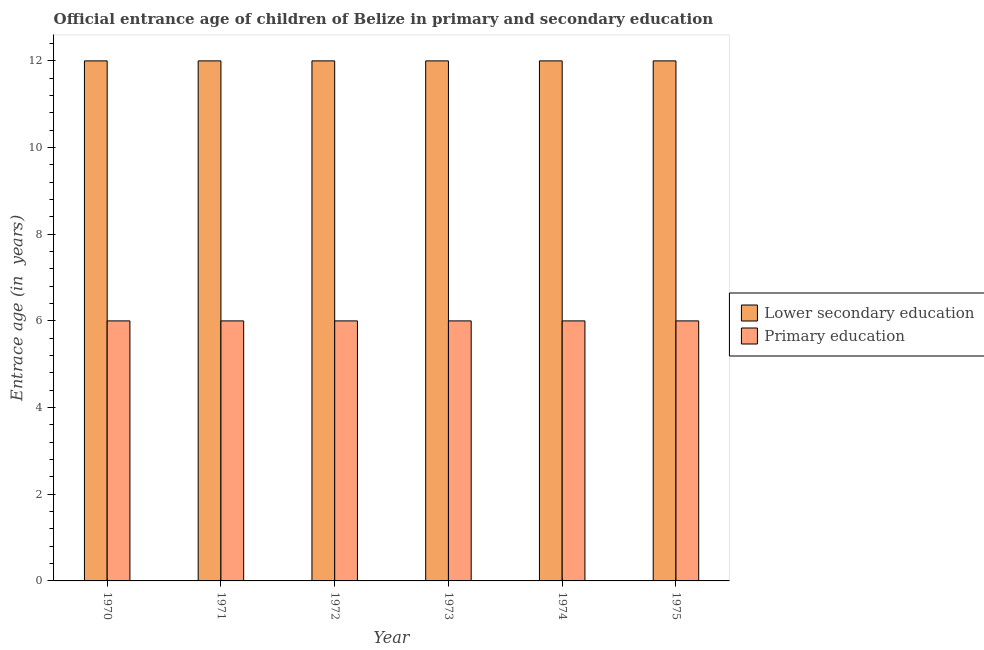How many different coloured bars are there?
Provide a short and direct response. 2. How many groups of bars are there?
Make the answer very short. 6. Are the number of bars per tick equal to the number of legend labels?
Keep it short and to the point. Yes. Are the number of bars on each tick of the X-axis equal?
Give a very brief answer. Yes. How many bars are there on the 1st tick from the left?
Keep it short and to the point. 2. What is the label of the 4th group of bars from the left?
Provide a short and direct response. 1973. Across all years, what is the maximum entrance age of chiildren in primary education?
Make the answer very short. 6. Across all years, what is the minimum entrance age of children in lower secondary education?
Your answer should be very brief. 12. In which year was the entrance age of children in lower secondary education minimum?
Ensure brevity in your answer.  1970. What is the total entrance age of chiildren in primary education in the graph?
Give a very brief answer. 36. What is the difference between the entrance age of chiildren in primary education in 1973 and the entrance age of children in lower secondary education in 1972?
Provide a short and direct response. 0. In the year 1972, what is the difference between the entrance age of chiildren in primary education and entrance age of children in lower secondary education?
Give a very brief answer. 0. In how many years, is the entrance age of children in lower secondary education greater than 11.2 years?
Offer a very short reply. 6. Is the difference between the entrance age of children in lower secondary education in 1973 and 1974 greater than the difference between the entrance age of chiildren in primary education in 1973 and 1974?
Your response must be concise. No. In how many years, is the entrance age of chiildren in primary education greater than the average entrance age of chiildren in primary education taken over all years?
Offer a terse response. 0. Is the sum of the entrance age of chiildren in primary education in 1971 and 1974 greater than the maximum entrance age of children in lower secondary education across all years?
Provide a succinct answer. Yes. Does the graph contain any zero values?
Your answer should be compact. No. How are the legend labels stacked?
Offer a terse response. Vertical. What is the title of the graph?
Offer a very short reply. Official entrance age of children of Belize in primary and secondary education. Does "Female labourers" appear as one of the legend labels in the graph?
Make the answer very short. No. What is the label or title of the X-axis?
Your answer should be very brief. Year. What is the label or title of the Y-axis?
Keep it short and to the point. Entrace age (in  years). What is the Entrace age (in  years) of Primary education in 1970?
Make the answer very short. 6. What is the Entrace age (in  years) of Lower secondary education in 1971?
Provide a short and direct response. 12. What is the Entrace age (in  years) in Lower secondary education in 1972?
Keep it short and to the point. 12. What is the Entrace age (in  years) of Lower secondary education in 1973?
Your answer should be very brief. 12. What is the Entrace age (in  years) in Primary education in 1973?
Offer a very short reply. 6. What is the Entrace age (in  years) of Primary education in 1975?
Provide a succinct answer. 6. Across all years, what is the maximum Entrace age (in  years) in Lower secondary education?
Give a very brief answer. 12. Across all years, what is the maximum Entrace age (in  years) of Primary education?
Your response must be concise. 6. What is the difference between the Entrace age (in  years) in Lower secondary education in 1970 and that in 1971?
Offer a terse response. 0. What is the difference between the Entrace age (in  years) of Primary education in 1970 and that in 1971?
Your answer should be very brief. 0. What is the difference between the Entrace age (in  years) of Lower secondary education in 1970 and that in 1972?
Ensure brevity in your answer.  0. What is the difference between the Entrace age (in  years) in Primary education in 1970 and that in 1972?
Offer a very short reply. 0. What is the difference between the Entrace age (in  years) in Primary education in 1970 and that in 1973?
Give a very brief answer. 0. What is the difference between the Entrace age (in  years) of Primary education in 1970 and that in 1975?
Provide a succinct answer. 0. What is the difference between the Entrace age (in  years) of Lower secondary education in 1971 and that in 1972?
Your answer should be compact. 0. What is the difference between the Entrace age (in  years) of Primary education in 1971 and that in 1975?
Ensure brevity in your answer.  0. What is the difference between the Entrace age (in  years) in Primary education in 1972 and that in 1973?
Your answer should be very brief. 0. What is the difference between the Entrace age (in  years) of Lower secondary education in 1972 and that in 1974?
Offer a very short reply. 0. What is the difference between the Entrace age (in  years) in Lower secondary education in 1972 and that in 1975?
Your answer should be compact. 0. What is the difference between the Entrace age (in  years) in Lower secondary education in 1973 and that in 1974?
Your response must be concise. 0. What is the difference between the Entrace age (in  years) in Lower secondary education in 1973 and that in 1975?
Give a very brief answer. 0. What is the difference between the Entrace age (in  years) in Primary education in 1973 and that in 1975?
Provide a succinct answer. 0. What is the difference between the Entrace age (in  years) of Lower secondary education in 1974 and that in 1975?
Keep it short and to the point. 0. What is the difference between the Entrace age (in  years) of Lower secondary education in 1970 and the Entrace age (in  years) of Primary education in 1972?
Provide a short and direct response. 6. What is the difference between the Entrace age (in  years) of Lower secondary education in 1971 and the Entrace age (in  years) of Primary education in 1973?
Provide a succinct answer. 6. What is the difference between the Entrace age (in  years) in Lower secondary education in 1971 and the Entrace age (in  years) in Primary education in 1974?
Provide a short and direct response. 6. What is the difference between the Entrace age (in  years) of Lower secondary education in 1972 and the Entrace age (in  years) of Primary education in 1973?
Provide a short and direct response. 6. What is the difference between the Entrace age (in  years) in Lower secondary education in 1972 and the Entrace age (in  years) in Primary education in 1974?
Your response must be concise. 6. What is the difference between the Entrace age (in  years) of Lower secondary education in 1973 and the Entrace age (in  years) of Primary education in 1974?
Make the answer very short. 6. What is the difference between the Entrace age (in  years) of Lower secondary education in 1973 and the Entrace age (in  years) of Primary education in 1975?
Offer a terse response. 6. What is the average Entrace age (in  years) in Primary education per year?
Ensure brevity in your answer.  6. In the year 1970, what is the difference between the Entrace age (in  years) in Lower secondary education and Entrace age (in  years) in Primary education?
Offer a very short reply. 6. In the year 1972, what is the difference between the Entrace age (in  years) of Lower secondary education and Entrace age (in  years) of Primary education?
Give a very brief answer. 6. In the year 1973, what is the difference between the Entrace age (in  years) of Lower secondary education and Entrace age (in  years) of Primary education?
Give a very brief answer. 6. In the year 1974, what is the difference between the Entrace age (in  years) of Lower secondary education and Entrace age (in  years) of Primary education?
Make the answer very short. 6. What is the ratio of the Entrace age (in  years) of Lower secondary education in 1970 to that in 1971?
Your answer should be very brief. 1. What is the ratio of the Entrace age (in  years) of Primary education in 1970 to that in 1971?
Make the answer very short. 1. What is the ratio of the Entrace age (in  years) in Lower secondary education in 1970 to that in 1973?
Provide a succinct answer. 1. What is the ratio of the Entrace age (in  years) of Primary education in 1970 to that in 1974?
Give a very brief answer. 1. What is the ratio of the Entrace age (in  years) in Lower secondary education in 1971 to that in 1973?
Your answer should be compact. 1. What is the ratio of the Entrace age (in  years) of Primary education in 1971 to that in 1974?
Offer a very short reply. 1. What is the ratio of the Entrace age (in  years) of Lower secondary education in 1971 to that in 1975?
Your answer should be compact. 1. What is the ratio of the Entrace age (in  years) in Lower secondary education in 1972 to that in 1973?
Offer a very short reply. 1. What is the ratio of the Entrace age (in  years) in Primary education in 1972 to that in 1973?
Offer a terse response. 1. What is the ratio of the Entrace age (in  years) of Lower secondary education in 1972 to that in 1974?
Provide a succinct answer. 1. What is the ratio of the Entrace age (in  years) of Lower secondary education in 1972 to that in 1975?
Provide a succinct answer. 1. What is the ratio of the Entrace age (in  years) in Lower secondary education in 1973 to that in 1974?
Keep it short and to the point. 1. What is the ratio of the Entrace age (in  years) of Primary education in 1973 to that in 1975?
Offer a terse response. 1. What is the difference between the highest and the lowest Entrace age (in  years) of Primary education?
Ensure brevity in your answer.  0. 